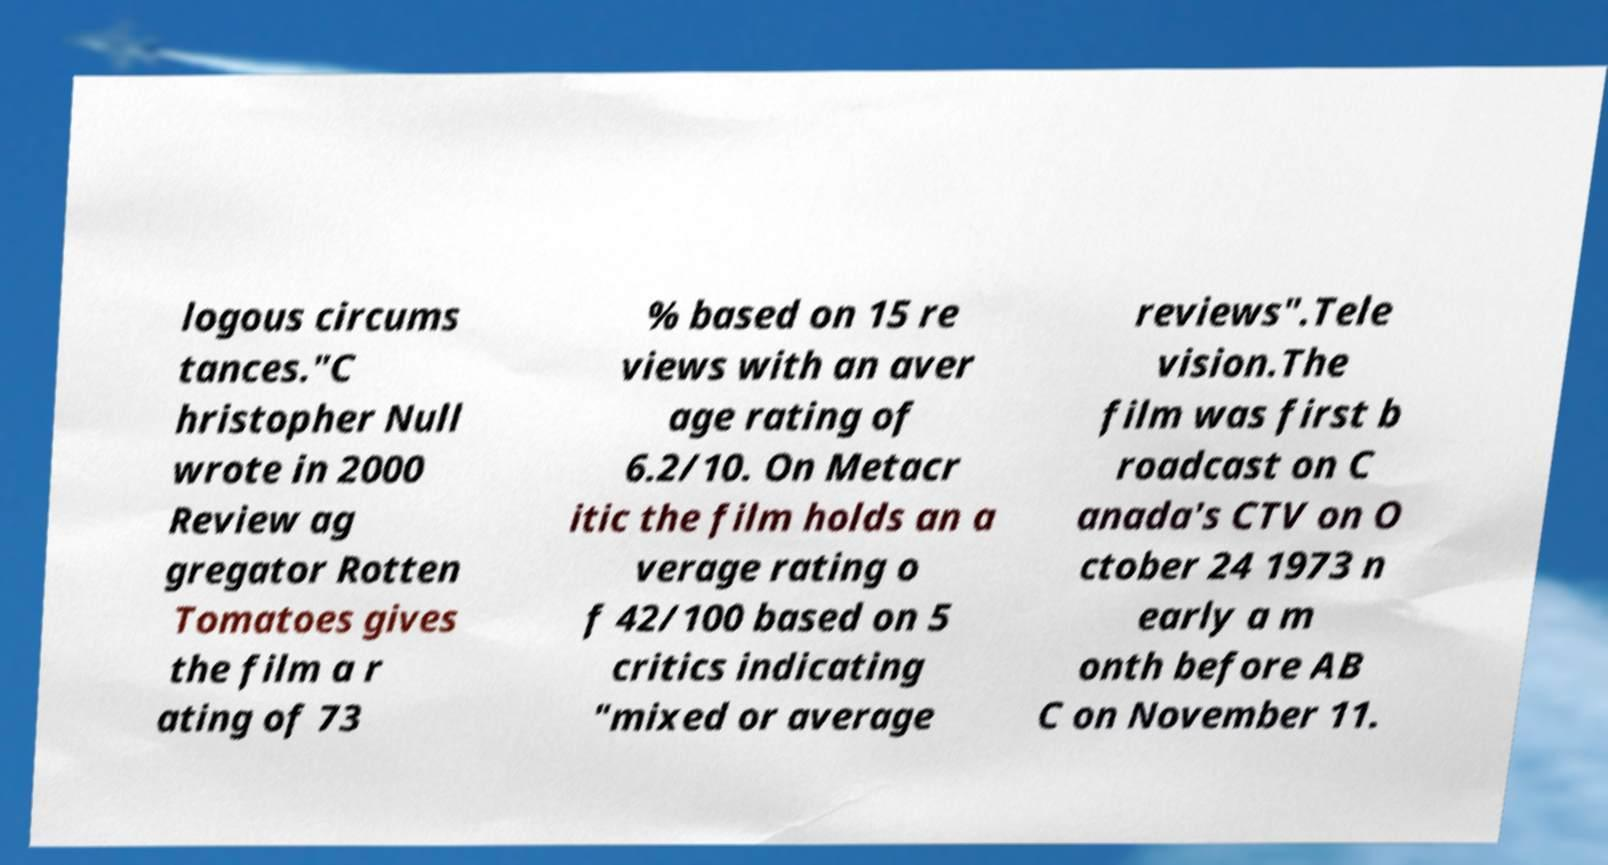I need the written content from this picture converted into text. Can you do that? logous circums tances."C hristopher Null wrote in 2000 Review ag gregator Rotten Tomatoes gives the film a r ating of 73 % based on 15 re views with an aver age rating of 6.2/10. On Metacr itic the film holds an a verage rating o f 42/100 based on 5 critics indicating "mixed or average reviews".Tele vision.The film was first b roadcast on C anada's CTV on O ctober 24 1973 n early a m onth before AB C on November 11. 